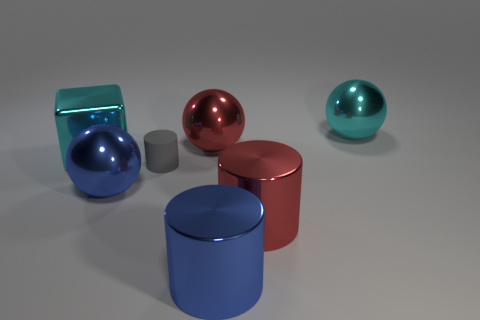How many objects are both in front of the large shiny cube and behind the red cylinder?
Give a very brief answer. 2. The shiny cylinder in front of the red shiny object on the right side of the large blue metallic cylinder is what color?
Provide a short and direct response. Blue. What number of metal things have the same color as the metal cube?
Your answer should be very brief. 1. There is a large cube; is it the same color as the large metal sphere on the right side of the large red cylinder?
Offer a terse response. Yes. Is the number of small cylinders less than the number of brown shiny objects?
Ensure brevity in your answer.  No. Is the number of gray cylinders that are behind the cyan shiny ball greater than the number of small matte things that are to the right of the large red metallic ball?
Your answer should be compact. No. Is the material of the cube the same as the tiny gray cylinder?
Keep it short and to the point. No. How many rubber things are in front of the blue metal object behind the blue cylinder?
Keep it short and to the point. 0. There is a big ball on the right side of the big blue shiny cylinder; is it the same color as the cube?
Provide a short and direct response. Yes. What number of things are either big red metallic balls or objects that are behind the tiny gray cylinder?
Your answer should be compact. 3. 